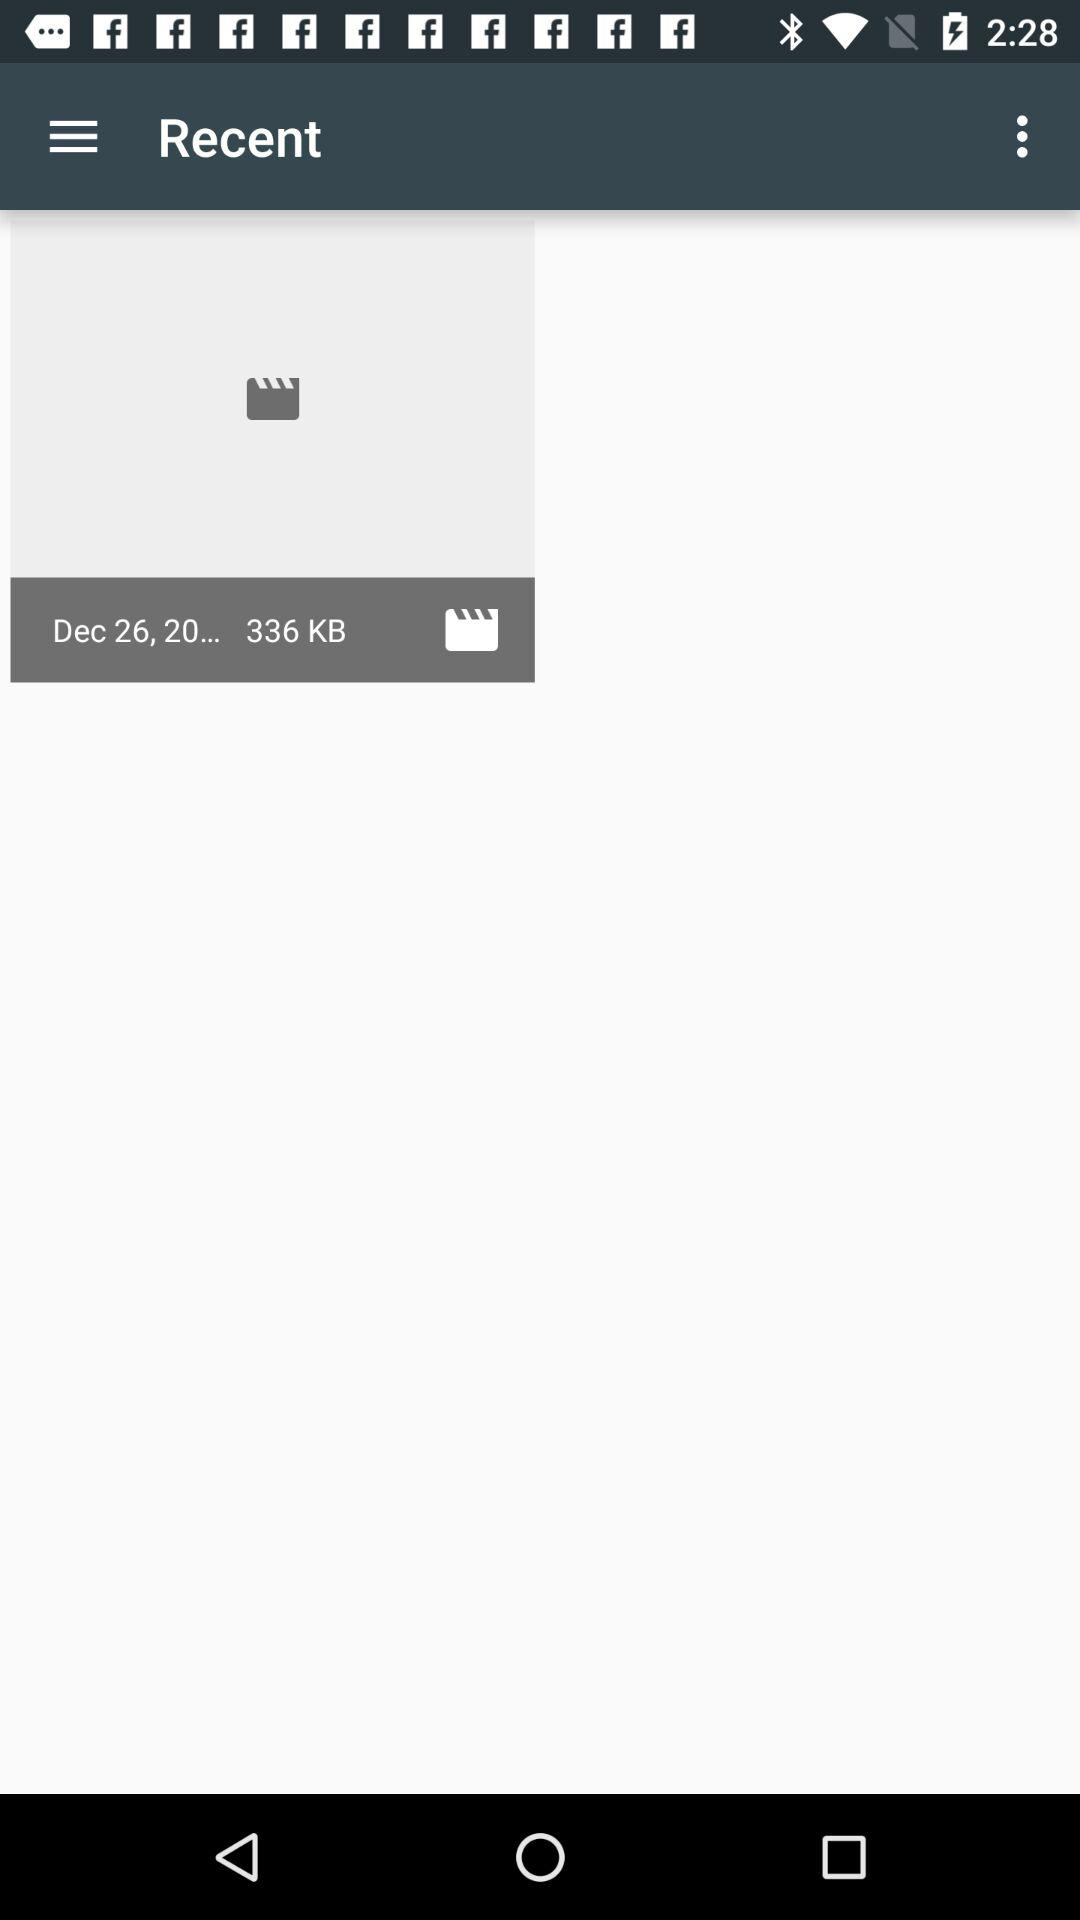What is the date of the file in "Recent"? The date is "Dec 26, 20...". 